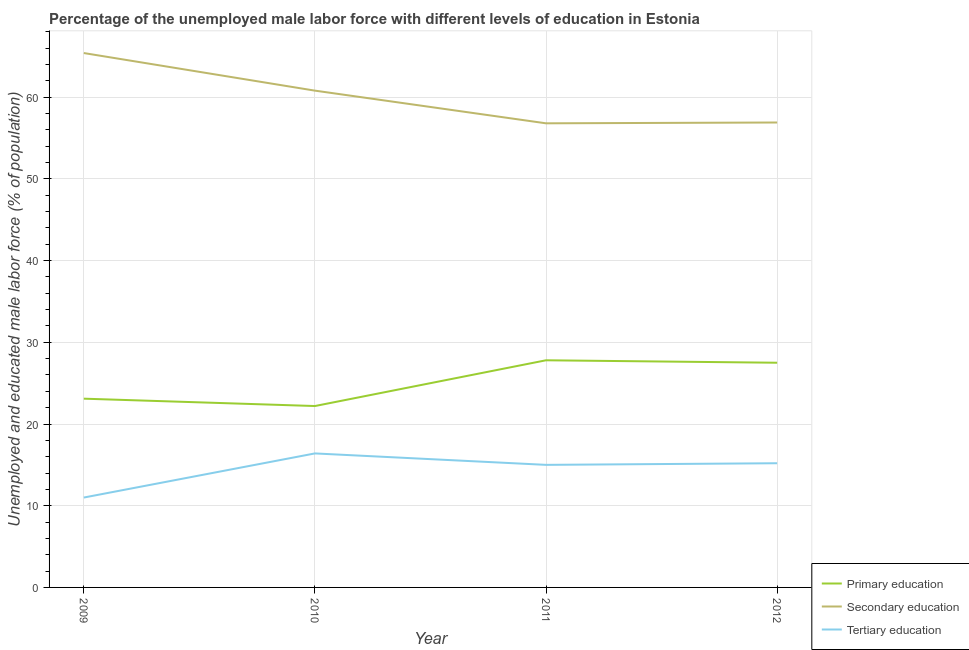How many different coloured lines are there?
Your response must be concise. 3. Does the line corresponding to percentage of male labor force who received primary education intersect with the line corresponding to percentage of male labor force who received tertiary education?
Offer a very short reply. No. What is the percentage of male labor force who received tertiary education in 2010?
Give a very brief answer. 16.4. Across all years, what is the maximum percentage of male labor force who received secondary education?
Provide a short and direct response. 65.4. Across all years, what is the minimum percentage of male labor force who received secondary education?
Make the answer very short. 56.8. In which year was the percentage of male labor force who received tertiary education maximum?
Give a very brief answer. 2010. What is the total percentage of male labor force who received tertiary education in the graph?
Ensure brevity in your answer.  57.6. What is the difference between the percentage of male labor force who received secondary education in 2011 and that in 2012?
Make the answer very short. -0.1. What is the difference between the percentage of male labor force who received primary education in 2011 and the percentage of male labor force who received tertiary education in 2009?
Your answer should be compact. 16.8. What is the average percentage of male labor force who received primary education per year?
Ensure brevity in your answer.  25.15. In the year 2011, what is the difference between the percentage of male labor force who received primary education and percentage of male labor force who received secondary education?
Give a very brief answer. -29. In how many years, is the percentage of male labor force who received secondary education greater than 40 %?
Ensure brevity in your answer.  4. What is the ratio of the percentage of male labor force who received tertiary education in 2009 to that in 2012?
Offer a very short reply. 0.72. Is the percentage of male labor force who received secondary education in 2010 less than that in 2012?
Ensure brevity in your answer.  No. What is the difference between the highest and the second highest percentage of male labor force who received secondary education?
Make the answer very short. 4.6. What is the difference between the highest and the lowest percentage of male labor force who received tertiary education?
Your response must be concise. 5.4. In how many years, is the percentage of male labor force who received secondary education greater than the average percentage of male labor force who received secondary education taken over all years?
Your answer should be very brief. 2. Is the sum of the percentage of male labor force who received tertiary education in 2009 and 2010 greater than the maximum percentage of male labor force who received primary education across all years?
Your response must be concise. No. Is it the case that in every year, the sum of the percentage of male labor force who received primary education and percentage of male labor force who received secondary education is greater than the percentage of male labor force who received tertiary education?
Your response must be concise. Yes. Is the percentage of male labor force who received secondary education strictly greater than the percentage of male labor force who received primary education over the years?
Your response must be concise. Yes. How many years are there in the graph?
Your answer should be very brief. 4. Does the graph contain any zero values?
Make the answer very short. No. Does the graph contain grids?
Give a very brief answer. Yes. How are the legend labels stacked?
Give a very brief answer. Vertical. What is the title of the graph?
Your answer should be compact. Percentage of the unemployed male labor force with different levels of education in Estonia. Does "Central government" appear as one of the legend labels in the graph?
Make the answer very short. No. What is the label or title of the X-axis?
Your answer should be very brief. Year. What is the label or title of the Y-axis?
Provide a succinct answer. Unemployed and educated male labor force (% of population). What is the Unemployed and educated male labor force (% of population) in Primary education in 2009?
Provide a succinct answer. 23.1. What is the Unemployed and educated male labor force (% of population) in Secondary education in 2009?
Provide a succinct answer. 65.4. What is the Unemployed and educated male labor force (% of population) of Primary education in 2010?
Your response must be concise. 22.2. What is the Unemployed and educated male labor force (% of population) of Secondary education in 2010?
Offer a very short reply. 60.8. What is the Unemployed and educated male labor force (% of population) in Tertiary education in 2010?
Keep it short and to the point. 16.4. What is the Unemployed and educated male labor force (% of population) of Primary education in 2011?
Offer a terse response. 27.8. What is the Unemployed and educated male labor force (% of population) of Secondary education in 2011?
Provide a short and direct response. 56.8. What is the Unemployed and educated male labor force (% of population) of Tertiary education in 2011?
Your answer should be very brief. 15. What is the Unemployed and educated male labor force (% of population) of Primary education in 2012?
Make the answer very short. 27.5. What is the Unemployed and educated male labor force (% of population) of Secondary education in 2012?
Provide a succinct answer. 56.9. What is the Unemployed and educated male labor force (% of population) in Tertiary education in 2012?
Your answer should be very brief. 15.2. Across all years, what is the maximum Unemployed and educated male labor force (% of population) in Primary education?
Ensure brevity in your answer.  27.8. Across all years, what is the maximum Unemployed and educated male labor force (% of population) of Secondary education?
Your answer should be compact. 65.4. Across all years, what is the maximum Unemployed and educated male labor force (% of population) of Tertiary education?
Your answer should be compact. 16.4. Across all years, what is the minimum Unemployed and educated male labor force (% of population) of Primary education?
Give a very brief answer. 22.2. Across all years, what is the minimum Unemployed and educated male labor force (% of population) in Secondary education?
Offer a terse response. 56.8. What is the total Unemployed and educated male labor force (% of population) of Primary education in the graph?
Your answer should be compact. 100.6. What is the total Unemployed and educated male labor force (% of population) of Secondary education in the graph?
Your response must be concise. 239.9. What is the total Unemployed and educated male labor force (% of population) in Tertiary education in the graph?
Offer a very short reply. 57.6. What is the difference between the Unemployed and educated male labor force (% of population) of Tertiary education in 2009 and that in 2010?
Your response must be concise. -5.4. What is the difference between the Unemployed and educated male labor force (% of population) of Tertiary education in 2009 and that in 2011?
Your response must be concise. -4. What is the difference between the Unemployed and educated male labor force (% of population) in Primary education in 2009 and that in 2012?
Offer a very short reply. -4.4. What is the difference between the Unemployed and educated male labor force (% of population) in Secondary education in 2010 and that in 2011?
Give a very brief answer. 4. What is the difference between the Unemployed and educated male labor force (% of population) of Primary education in 2010 and that in 2012?
Make the answer very short. -5.3. What is the difference between the Unemployed and educated male labor force (% of population) of Primary education in 2011 and that in 2012?
Make the answer very short. 0.3. What is the difference between the Unemployed and educated male labor force (% of population) of Tertiary education in 2011 and that in 2012?
Your response must be concise. -0.2. What is the difference between the Unemployed and educated male labor force (% of population) of Primary education in 2009 and the Unemployed and educated male labor force (% of population) of Secondary education in 2010?
Your answer should be very brief. -37.7. What is the difference between the Unemployed and educated male labor force (% of population) in Primary education in 2009 and the Unemployed and educated male labor force (% of population) in Secondary education in 2011?
Offer a terse response. -33.7. What is the difference between the Unemployed and educated male labor force (% of population) of Primary education in 2009 and the Unemployed and educated male labor force (% of population) of Tertiary education in 2011?
Your response must be concise. 8.1. What is the difference between the Unemployed and educated male labor force (% of population) in Secondary education in 2009 and the Unemployed and educated male labor force (% of population) in Tertiary education in 2011?
Give a very brief answer. 50.4. What is the difference between the Unemployed and educated male labor force (% of population) in Primary education in 2009 and the Unemployed and educated male labor force (% of population) in Secondary education in 2012?
Ensure brevity in your answer.  -33.8. What is the difference between the Unemployed and educated male labor force (% of population) of Primary education in 2009 and the Unemployed and educated male labor force (% of population) of Tertiary education in 2012?
Your response must be concise. 7.9. What is the difference between the Unemployed and educated male labor force (% of population) of Secondary education in 2009 and the Unemployed and educated male labor force (% of population) of Tertiary education in 2012?
Provide a short and direct response. 50.2. What is the difference between the Unemployed and educated male labor force (% of population) in Primary education in 2010 and the Unemployed and educated male labor force (% of population) in Secondary education in 2011?
Make the answer very short. -34.6. What is the difference between the Unemployed and educated male labor force (% of population) of Primary education in 2010 and the Unemployed and educated male labor force (% of population) of Tertiary education in 2011?
Your response must be concise. 7.2. What is the difference between the Unemployed and educated male labor force (% of population) in Secondary education in 2010 and the Unemployed and educated male labor force (% of population) in Tertiary education in 2011?
Offer a very short reply. 45.8. What is the difference between the Unemployed and educated male labor force (% of population) in Primary education in 2010 and the Unemployed and educated male labor force (% of population) in Secondary education in 2012?
Provide a short and direct response. -34.7. What is the difference between the Unemployed and educated male labor force (% of population) of Primary education in 2010 and the Unemployed and educated male labor force (% of population) of Tertiary education in 2012?
Your answer should be very brief. 7. What is the difference between the Unemployed and educated male labor force (% of population) in Secondary education in 2010 and the Unemployed and educated male labor force (% of population) in Tertiary education in 2012?
Your answer should be very brief. 45.6. What is the difference between the Unemployed and educated male labor force (% of population) of Primary education in 2011 and the Unemployed and educated male labor force (% of population) of Secondary education in 2012?
Your response must be concise. -29.1. What is the difference between the Unemployed and educated male labor force (% of population) in Primary education in 2011 and the Unemployed and educated male labor force (% of population) in Tertiary education in 2012?
Give a very brief answer. 12.6. What is the difference between the Unemployed and educated male labor force (% of population) in Secondary education in 2011 and the Unemployed and educated male labor force (% of population) in Tertiary education in 2012?
Give a very brief answer. 41.6. What is the average Unemployed and educated male labor force (% of population) in Primary education per year?
Provide a short and direct response. 25.15. What is the average Unemployed and educated male labor force (% of population) in Secondary education per year?
Your answer should be compact. 59.98. What is the average Unemployed and educated male labor force (% of population) in Tertiary education per year?
Your response must be concise. 14.4. In the year 2009, what is the difference between the Unemployed and educated male labor force (% of population) of Primary education and Unemployed and educated male labor force (% of population) of Secondary education?
Offer a very short reply. -42.3. In the year 2009, what is the difference between the Unemployed and educated male labor force (% of population) in Secondary education and Unemployed and educated male labor force (% of population) in Tertiary education?
Your response must be concise. 54.4. In the year 2010, what is the difference between the Unemployed and educated male labor force (% of population) of Primary education and Unemployed and educated male labor force (% of population) of Secondary education?
Offer a very short reply. -38.6. In the year 2010, what is the difference between the Unemployed and educated male labor force (% of population) of Secondary education and Unemployed and educated male labor force (% of population) of Tertiary education?
Provide a succinct answer. 44.4. In the year 2011, what is the difference between the Unemployed and educated male labor force (% of population) of Primary education and Unemployed and educated male labor force (% of population) of Tertiary education?
Give a very brief answer. 12.8. In the year 2011, what is the difference between the Unemployed and educated male labor force (% of population) in Secondary education and Unemployed and educated male labor force (% of population) in Tertiary education?
Your answer should be compact. 41.8. In the year 2012, what is the difference between the Unemployed and educated male labor force (% of population) in Primary education and Unemployed and educated male labor force (% of population) in Secondary education?
Offer a terse response. -29.4. In the year 2012, what is the difference between the Unemployed and educated male labor force (% of population) in Primary education and Unemployed and educated male labor force (% of population) in Tertiary education?
Your answer should be compact. 12.3. In the year 2012, what is the difference between the Unemployed and educated male labor force (% of population) in Secondary education and Unemployed and educated male labor force (% of population) in Tertiary education?
Your response must be concise. 41.7. What is the ratio of the Unemployed and educated male labor force (% of population) in Primary education in 2009 to that in 2010?
Your response must be concise. 1.04. What is the ratio of the Unemployed and educated male labor force (% of population) in Secondary education in 2009 to that in 2010?
Ensure brevity in your answer.  1.08. What is the ratio of the Unemployed and educated male labor force (% of population) of Tertiary education in 2009 to that in 2010?
Keep it short and to the point. 0.67. What is the ratio of the Unemployed and educated male labor force (% of population) in Primary education in 2009 to that in 2011?
Provide a short and direct response. 0.83. What is the ratio of the Unemployed and educated male labor force (% of population) of Secondary education in 2009 to that in 2011?
Provide a short and direct response. 1.15. What is the ratio of the Unemployed and educated male labor force (% of population) in Tertiary education in 2009 to that in 2011?
Keep it short and to the point. 0.73. What is the ratio of the Unemployed and educated male labor force (% of population) in Primary education in 2009 to that in 2012?
Your response must be concise. 0.84. What is the ratio of the Unemployed and educated male labor force (% of population) in Secondary education in 2009 to that in 2012?
Ensure brevity in your answer.  1.15. What is the ratio of the Unemployed and educated male labor force (% of population) of Tertiary education in 2009 to that in 2012?
Offer a very short reply. 0.72. What is the ratio of the Unemployed and educated male labor force (% of population) of Primary education in 2010 to that in 2011?
Your answer should be very brief. 0.8. What is the ratio of the Unemployed and educated male labor force (% of population) in Secondary education in 2010 to that in 2011?
Your answer should be very brief. 1.07. What is the ratio of the Unemployed and educated male labor force (% of population) in Tertiary education in 2010 to that in 2011?
Offer a very short reply. 1.09. What is the ratio of the Unemployed and educated male labor force (% of population) of Primary education in 2010 to that in 2012?
Ensure brevity in your answer.  0.81. What is the ratio of the Unemployed and educated male labor force (% of population) in Secondary education in 2010 to that in 2012?
Provide a succinct answer. 1.07. What is the ratio of the Unemployed and educated male labor force (% of population) of Tertiary education in 2010 to that in 2012?
Your answer should be compact. 1.08. What is the ratio of the Unemployed and educated male labor force (% of population) of Primary education in 2011 to that in 2012?
Keep it short and to the point. 1.01. What is the ratio of the Unemployed and educated male labor force (% of population) of Secondary education in 2011 to that in 2012?
Offer a very short reply. 1. What is the ratio of the Unemployed and educated male labor force (% of population) in Tertiary education in 2011 to that in 2012?
Keep it short and to the point. 0.99. What is the difference between the highest and the second highest Unemployed and educated male labor force (% of population) in Primary education?
Provide a succinct answer. 0.3. What is the difference between the highest and the lowest Unemployed and educated male labor force (% of population) in Primary education?
Your response must be concise. 5.6. What is the difference between the highest and the lowest Unemployed and educated male labor force (% of population) in Secondary education?
Your answer should be compact. 8.6. What is the difference between the highest and the lowest Unemployed and educated male labor force (% of population) in Tertiary education?
Provide a succinct answer. 5.4. 